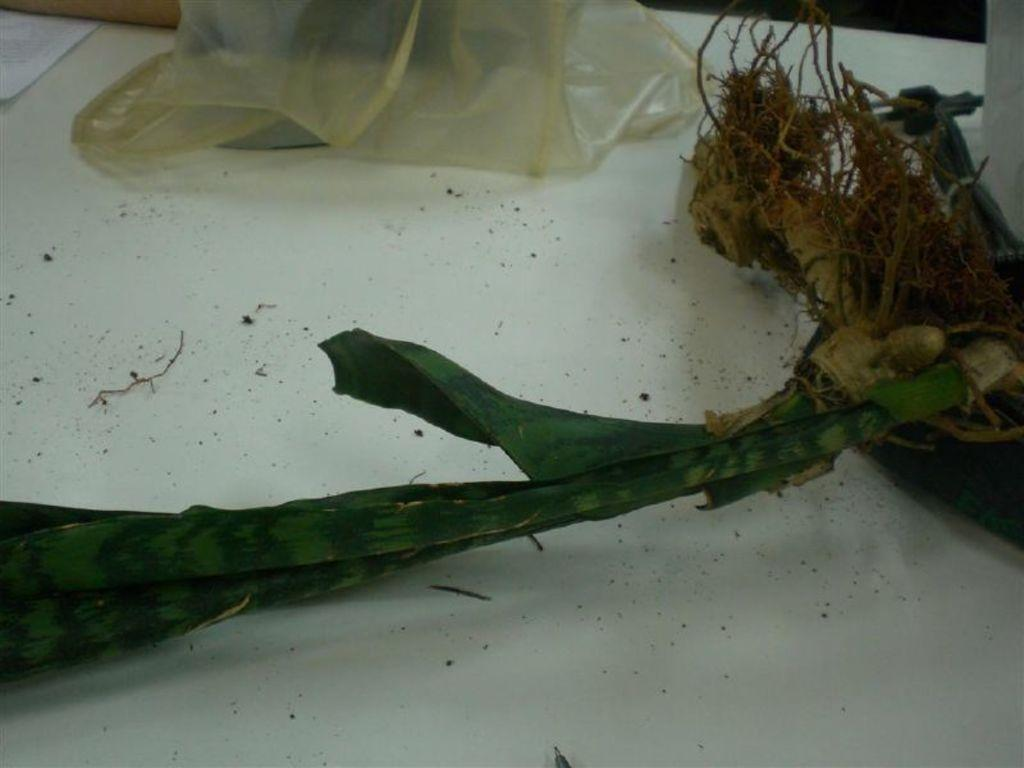What type of living organism is in the image? There is a plant in the image. What is covering the plant in the image? There is a plastic cover in the image. Where are the plant and plastic cover located? The plant and plastic cover are on a platform. What is the title of the country where the plant is located in the image? There is no information about the country or its title in the image. What season is depicted in the image? The image does not provide any information about the season, as it only features a plant and a plastic cover. 